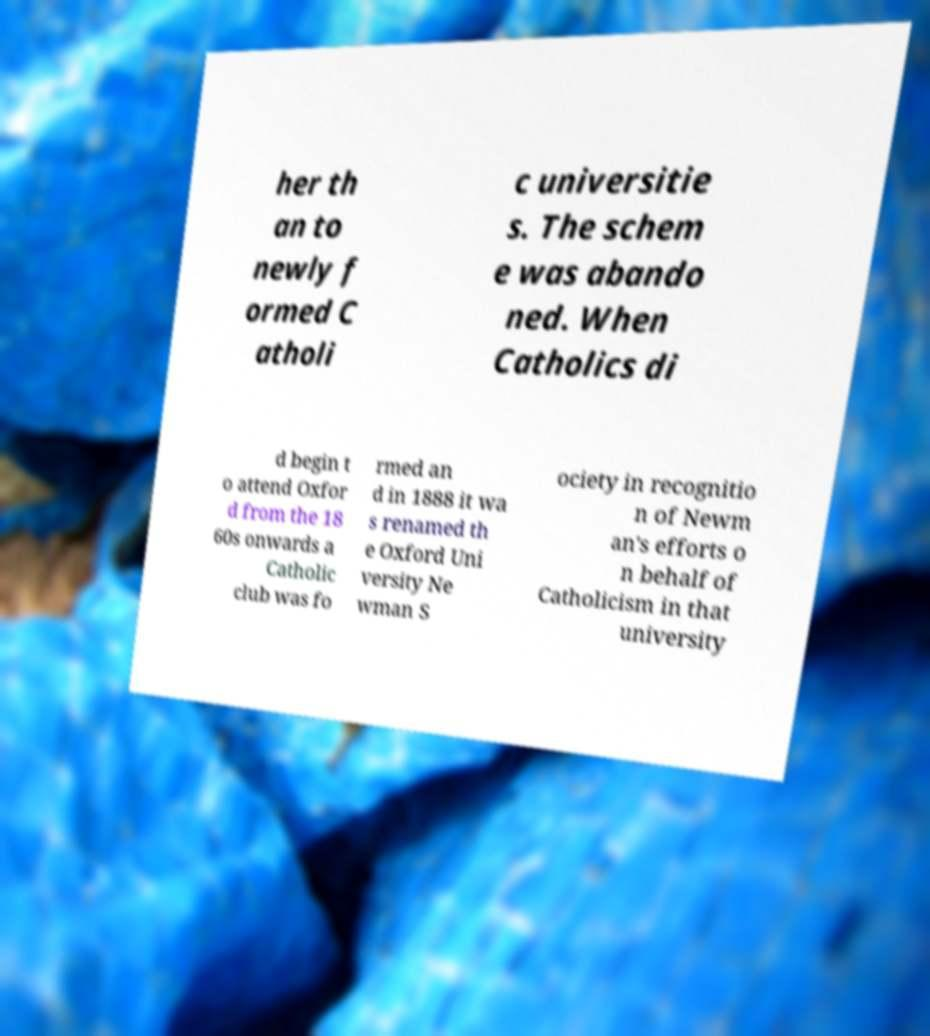There's text embedded in this image that I need extracted. Can you transcribe it verbatim? her th an to newly f ormed C atholi c universitie s. The schem e was abando ned. When Catholics di d begin t o attend Oxfor d from the 18 60s onwards a Catholic club was fo rmed an d in 1888 it wa s renamed th e Oxford Uni versity Ne wman S ociety in recognitio n of Newm an's efforts o n behalf of Catholicism in that university 